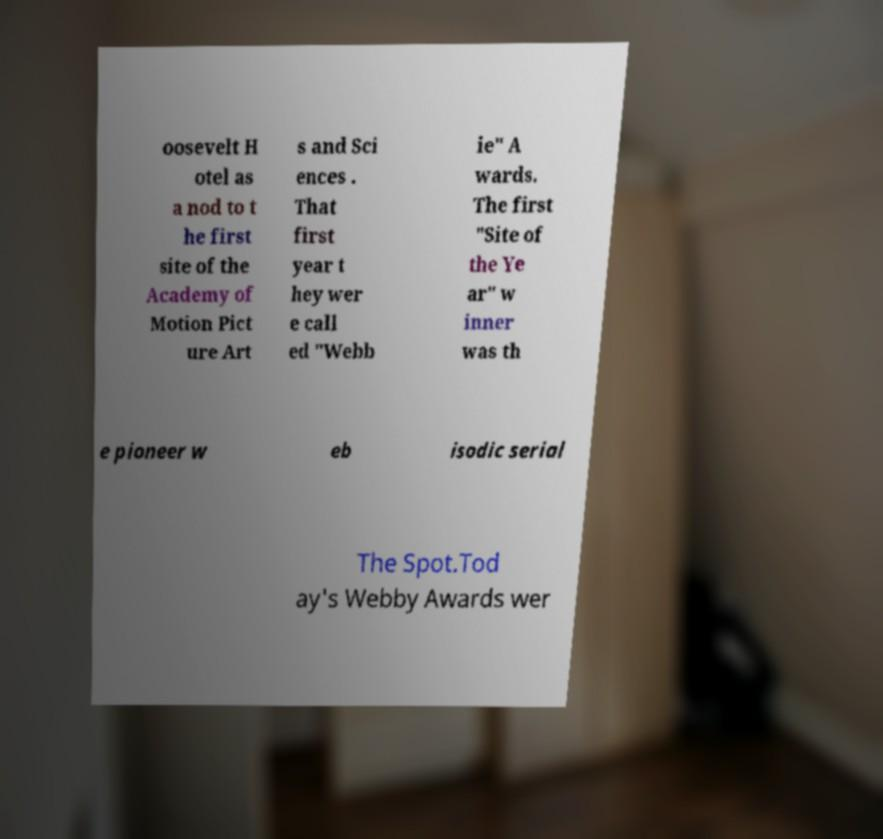I need the written content from this picture converted into text. Can you do that? oosevelt H otel as a nod to t he first site of the Academy of Motion Pict ure Art s and Sci ences . That first year t hey wer e call ed "Webb ie" A wards. The first "Site of the Ye ar" w inner was th e pioneer w eb isodic serial The Spot.Tod ay's Webby Awards wer 